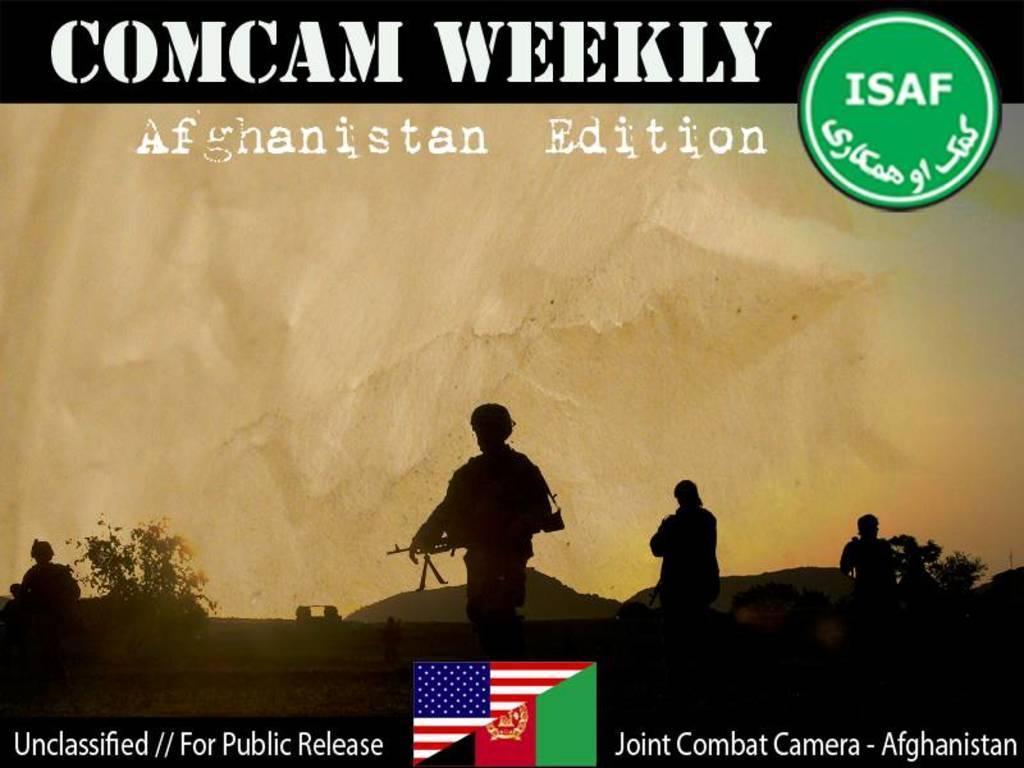What is the name of this publication?
Keep it short and to the point. Comcam weekly. Title of this magazine?
Ensure brevity in your answer.  Comcam weekly. What country is on the bottom right?
Ensure brevity in your answer.  Afghanistan. 